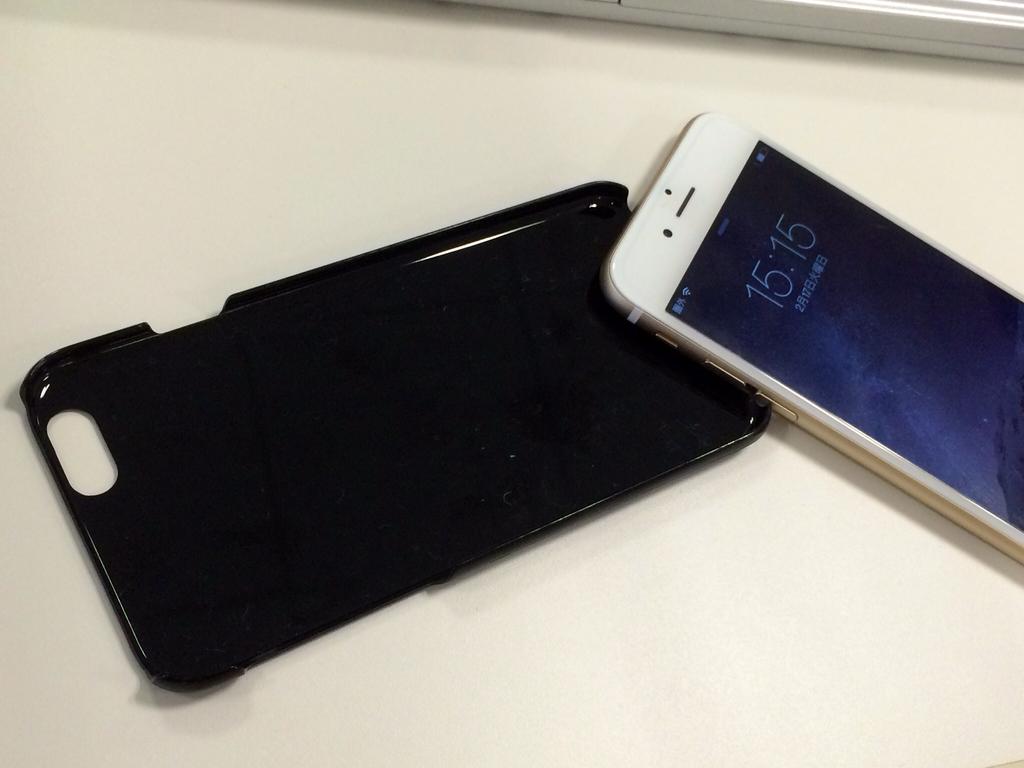What time is on the phone?
Your answer should be compact. 15:15. 